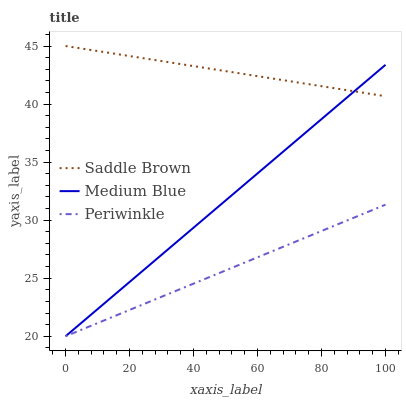Does Periwinkle have the minimum area under the curve?
Answer yes or no. Yes. Does Saddle Brown have the maximum area under the curve?
Answer yes or no. Yes. Does Medium Blue have the minimum area under the curve?
Answer yes or no. No. Does Medium Blue have the maximum area under the curve?
Answer yes or no. No. Is Medium Blue the smoothest?
Answer yes or no. Yes. Is Saddle Brown the roughest?
Answer yes or no. Yes. Is Saddle Brown the smoothest?
Answer yes or no. No. Is Medium Blue the roughest?
Answer yes or no. No. Does Periwinkle have the lowest value?
Answer yes or no. Yes. Does Saddle Brown have the lowest value?
Answer yes or no. No. Does Saddle Brown have the highest value?
Answer yes or no. Yes. Does Medium Blue have the highest value?
Answer yes or no. No. Is Periwinkle less than Saddle Brown?
Answer yes or no. Yes. Is Saddle Brown greater than Periwinkle?
Answer yes or no. Yes. Does Periwinkle intersect Medium Blue?
Answer yes or no. Yes. Is Periwinkle less than Medium Blue?
Answer yes or no. No. Is Periwinkle greater than Medium Blue?
Answer yes or no. No. Does Periwinkle intersect Saddle Brown?
Answer yes or no. No. 